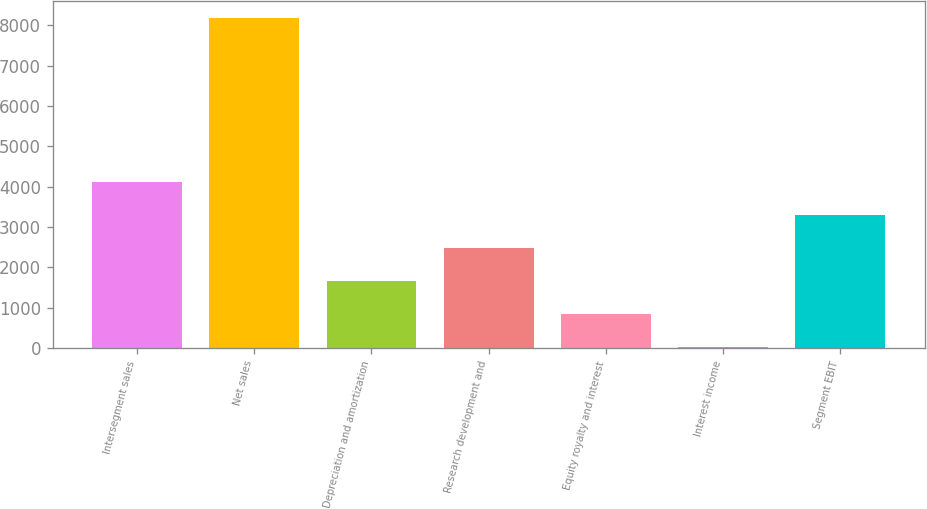Convert chart. <chart><loc_0><loc_0><loc_500><loc_500><bar_chart><fcel>Intersegment sales<fcel>Net sales<fcel>Depreciation and amortization<fcel>Research development and<fcel>Equity royalty and interest<fcel>Interest income<fcel>Segment EBIT<nl><fcel>4104<fcel>8182<fcel>1657.2<fcel>2472.8<fcel>841.6<fcel>26<fcel>3288.4<nl></chart> 